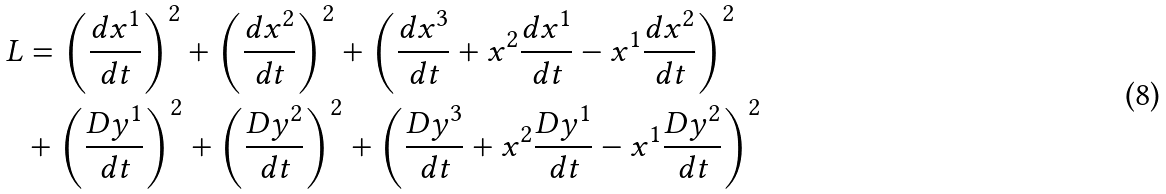Convert formula to latex. <formula><loc_0><loc_0><loc_500><loc_500>L & = \left ( \frac { d x ^ { 1 } } { d t } \right ) ^ { 2 } + \left ( \frac { d x ^ { 2 } } { d t } \right ) ^ { 2 } + \left ( \frac { d x ^ { 3 } } { d t } + x ^ { 2 } \frac { d x ^ { 1 } } { d t } - x ^ { 1 } \frac { d x ^ { 2 } } { d t } \right ) ^ { 2 } \\ & + \left ( \frac { D y ^ { 1 } } { d t } \right ) ^ { 2 } + \left ( \frac { D y ^ { 2 } } { d t } \right ) ^ { 2 } + \left ( \frac { D y ^ { 3 } } { d t } + x ^ { 2 } \frac { D y ^ { 1 } } { d t } - x ^ { 1 } \frac { D y ^ { 2 } } { d t } \right ) ^ { 2 }</formula> 